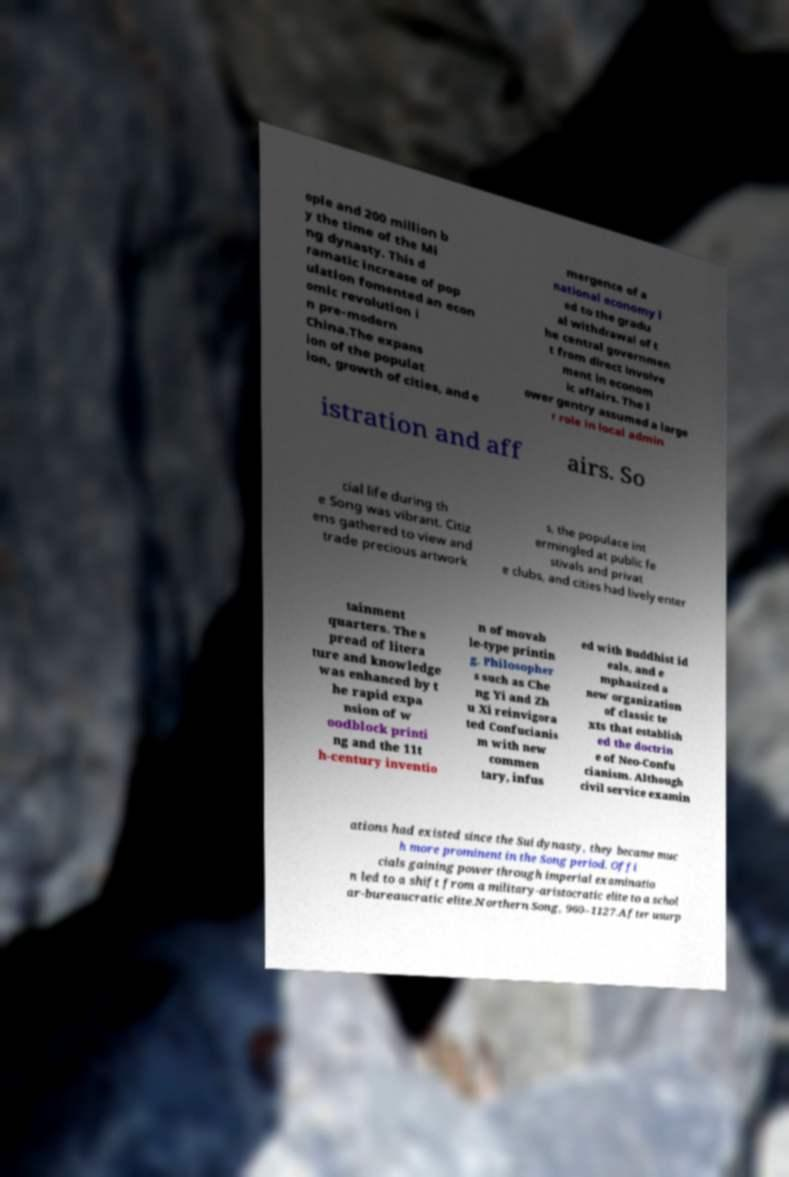For documentation purposes, I need the text within this image transcribed. Could you provide that? ople and 200 million b y the time of the Mi ng dynasty. This d ramatic increase of pop ulation fomented an econ omic revolution i n pre-modern China.The expans ion of the populat ion, growth of cities, and e mergence of a national economy l ed to the gradu al withdrawal of t he central governmen t from direct involve ment in econom ic affairs. The l ower gentry assumed a large r role in local admin istration and aff airs. So cial life during th e Song was vibrant. Citiz ens gathered to view and trade precious artwork s, the populace int ermingled at public fe stivals and privat e clubs, and cities had lively enter tainment quarters. The s pread of litera ture and knowledge was enhanced by t he rapid expa nsion of w oodblock printi ng and the 11t h-century inventio n of movab le-type printin g. Philosopher s such as Che ng Yi and Zh u Xi reinvigora ted Confucianis m with new commen tary, infus ed with Buddhist id eals, and e mphasized a new organization of classic te xts that establish ed the doctrin e of Neo-Confu cianism. Although civil service examin ations had existed since the Sui dynasty, they became muc h more prominent in the Song period. Offi cials gaining power through imperial examinatio n led to a shift from a military-aristocratic elite to a schol ar-bureaucratic elite.Northern Song, 960–1127.After usurp 